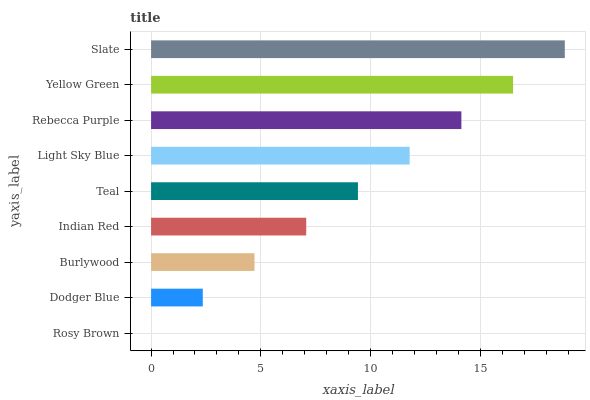Is Rosy Brown the minimum?
Answer yes or no. Yes. Is Slate the maximum?
Answer yes or no. Yes. Is Dodger Blue the minimum?
Answer yes or no. No. Is Dodger Blue the maximum?
Answer yes or no. No. Is Dodger Blue greater than Rosy Brown?
Answer yes or no. Yes. Is Rosy Brown less than Dodger Blue?
Answer yes or no. Yes. Is Rosy Brown greater than Dodger Blue?
Answer yes or no. No. Is Dodger Blue less than Rosy Brown?
Answer yes or no. No. Is Teal the high median?
Answer yes or no. Yes. Is Teal the low median?
Answer yes or no. Yes. Is Burlywood the high median?
Answer yes or no. No. Is Burlywood the low median?
Answer yes or no. No. 